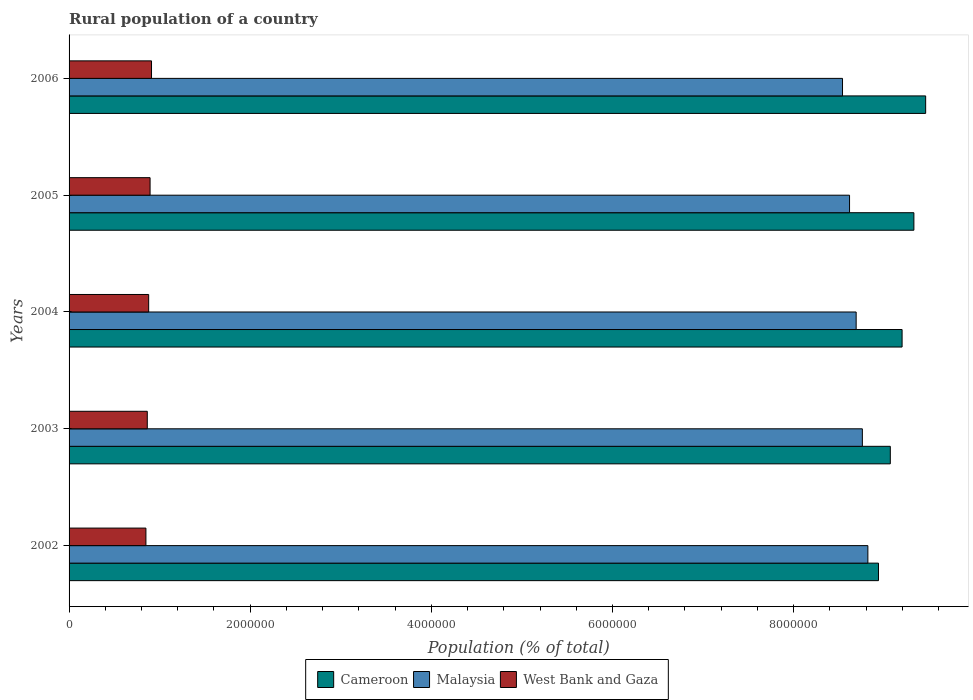How many bars are there on the 1st tick from the top?
Provide a succinct answer. 3. How many bars are there on the 5th tick from the bottom?
Provide a short and direct response. 3. In how many cases, is the number of bars for a given year not equal to the number of legend labels?
Provide a succinct answer. 0. What is the rural population in West Bank and Gaza in 2003?
Provide a short and direct response. 8.64e+05. Across all years, what is the maximum rural population in Malaysia?
Offer a very short reply. 8.82e+06. Across all years, what is the minimum rural population in Cameroon?
Your answer should be very brief. 8.94e+06. In which year was the rural population in Malaysia minimum?
Provide a succinct answer. 2006. What is the total rural population in West Bank and Gaza in the graph?
Offer a terse response. 4.40e+06. What is the difference between the rural population in Malaysia in 2005 and that in 2006?
Give a very brief answer. 7.75e+04. What is the difference between the rural population in West Bank and Gaza in 2005 and the rural population in Cameroon in 2003?
Your answer should be compact. -8.17e+06. What is the average rural population in Malaysia per year?
Provide a short and direct response. 8.69e+06. In the year 2004, what is the difference between the rural population in Malaysia and rural population in West Bank and Gaza?
Ensure brevity in your answer.  7.81e+06. In how many years, is the rural population in Malaysia greater than 2000000 %?
Provide a short and direct response. 5. What is the ratio of the rural population in West Bank and Gaza in 2004 to that in 2006?
Your answer should be compact. 0.97. What is the difference between the highest and the second highest rural population in West Bank and Gaza?
Offer a terse response. 1.58e+04. What is the difference between the highest and the lowest rural population in West Bank and Gaza?
Your response must be concise. 6.18e+04. In how many years, is the rural population in Cameroon greater than the average rural population in Cameroon taken over all years?
Keep it short and to the point. 3. Is the sum of the rural population in Malaysia in 2002 and 2004 greater than the maximum rural population in Cameroon across all years?
Your response must be concise. Yes. What does the 2nd bar from the top in 2006 represents?
Make the answer very short. Malaysia. What does the 3rd bar from the bottom in 2005 represents?
Your answer should be very brief. West Bank and Gaza. Is it the case that in every year, the sum of the rural population in Malaysia and rural population in Cameroon is greater than the rural population in West Bank and Gaza?
Make the answer very short. Yes. How many bars are there?
Provide a short and direct response. 15. How many years are there in the graph?
Ensure brevity in your answer.  5. Are the values on the major ticks of X-axis written in scientific E-notation?
Give a very brief answer. No. Does the graph contain grids?
Offer a very short reply. No. Where does the legend appear in the graph?
Your answer should be compact. Bottom center. How many legend labels are there?
Offer a very short reply. 3. What is the title of the graph?
Give a very brief answer. Rural population of a country. What is the label or title of the X-axis?
Ensure brevity in your answer.  Population (% of total). What is the Population (% of total) in Cameroon in 2002?
Make the answer very short. 8.94e+06. What is the Population (% of total) in Malaysia in 2002?
Offer a terse response. 8.82e+06. What is the Population (% of total) of West Bank and Gaza in 2002?
Offer a terse response. 8.49e+05. What is the Population (% of total) in Cameroon in 2003?
Keep it short and to the point. 9.07e+06. What is the Population (% of total) in Malaysia in 2003?
Offer a very short reply. 8.76e+06. What is the Population (% of total) in West Bank and Gaza in 2003?
Make the answer very short. 8.64e+05. What is the Population (% of total) in Cameroon in 2004?
Your answer should be compact. 9.20e+06. What is the Population (% of total) of Malaysia in 2004?
Give a very brief answer. 8.69e+06. What is the Population (% of total) of West Bank and Gaza in 2004?
Give a very brief answer. 8.79e+05. What is the Population (% of total) of Cameroon in 2005?
Give a very brief answer. 9.33e+06. What is the Population (% of total) in Malaysia in 2005?
Make the answer very short. 8.62e+06. What is the Population (% of total) of West Bank and Gaza in 2005?
Offer a terse response. 8.94e+05. What is the Population (% of total) of Cameroon in 2006?
Give a very brief answer. 9.46e+06. What is the Population (% of total) in Malaysia in 2006?
Your answer should be compact. 8.54e+06. What is the Population (% of total) in West Bank and Gaza in 2006?
Keep it short and to the point. 9.10e+05. Across all years, what is the maximum Population (% of total) of Cameroon?
Offer a terse response. 9.46e+06. Across all years, what is the maximum Population (% of total) of Malaysia?
Your response must be concise. 8.82e+06. Across all years, what is the maximum Population (% of total) in West Bank and Gaza?
Give a very brief answer. 9.10e+05. Across all years, what is the minimum Population (% of total) of Cameroon?
Your answer should be compact. 8.94e+06. Across all years, what is the minimum Population (% of total) in Malaysia?
Offer a very short reply. 8.54e+06. Across all years, what is the minimum Population (% of total) in West Bank and Gaza?
Provide a succinct answer. 8.49e+05. What is the total Population (% of total) of Cameroon in the graph?
Your answer should be very brief. 4.60e+07. What is the total Population (% of total) of Malaysia in the graph?
Offer a very short reply. 4.34e+07. What is the total Population (% of total) in West Bank and Gaza in the graph?
Provide a short and direct response. 4.40e+06. What is the difference between the Population (% of total) of Cameroon in 2002 and that in 2003?
Ensure brevity in your answer.  -1.31e+05. What is the difference between the Population (% of total) in Malaysia in 2002 and that in 2003?
Give a very brief answer. 6.08e+04. What is the difference between the Population (% of total) of West Bank and Gaza in 2002 and that in 2003?
Ensure brevity in your answer.  -1.51e+04. What is the difference between the Population (% of total) in Cameroon in 2002 and that in 2004?
Your answer should be very brief. -2.61e+05. What is the difference between the Population (% of total) of Malaysia in 2002 and that in 2004?
Offer a terse response. 1.29e+05. What is the difference between the Population (% of total) in West Bank and Gaza in 2002 and that in 2004?
Give a very brief answer. -3.04e+04. What is the difference between the Population (% of total) in Cameroon in 2002 and that in 2005?
Your response must be concise. -3.91e+05. What is the difference between the Population (% of total) of Malaysia in 2002 and that in 2005?
Provide a succinct answer. 2.02e+05. What is the difference between the Population (% of total) of West Bank and Gaza in 2002 and that in 2005?
Make the answer very short. -4.60e+04. What is the difference between the Population (% of total) in Cameroon in 2002 and that in 2006?
Your response must be concise. -5.21e+05. What is the difference between the Population (% of total) of Malaysia in 2002 and that in 2006?
Your answer should be very brief. 2.80e+05. What is the difference between the Population (% of total) in West Bank and Gaza in 2002 and that in 2006?
Give a very brief answer. -6.18e+04. What is the difference between the Population (% of total) of Cameroon in 2003 and that in 2004?
Your response must be concise. -1.30e+05. What is the difference between the Population (% of total) in Malaysia in 2003 and that in 2004?
Provide a short and direct response. 6.86e+04. What is the difference between the Population (% of total) in West Bank and Gaza in 2003 and that in 2004?
Provide a succinct answer. -1.53e+04. What is the difference between the Population (% of total) of Cameroon in 2003 and that in 2005?
Offer a terse response. -2.60e+05. What is the difference between the Population (% of total) in Malaysia in 2003 and that in 2005?
Your response must be concise. 1.42e+05. What is the difference between the Population (% of total) of West Bank and Gaza in 2003 and that in 2005?
Offer a terse response. -3.09e+04. What is the difference between the Population (% of total) of Cameroon in 2003 and that in 2006?
Give a very brief answer. -3.90e+05. What is the difference between the Population (% of total) in Malaysia in 2003 and that in 2006?
Your answer should be very brief. 2.19e+05. What is the difference between the Population (% of total) of West Bank and Gaza in 2003 and that in 2006?
Keep it short and to the point. -4.67e+04. What is the difference between the Population (% of total) in Cameroon in 2004 and that in 2005?
Provide a succinct answer. -1.30e+05. What is the difference between the Population (% of total) of Malaysia in 2004 and that in 2005?
Give a very brief answer. 7.30e+04. What is the difference between the Population (% of total) of West Bank and Gaza in 2004 and that in 2005?
Your answer should be compact. -1.56e+04. What is the difference between the Population (% of total) of Cameroon in 2004 and that in 2006?
Provide a short and direct response. -2.60e+05. What is the difference between the Population (% of total) of Malaysia in 2004 and that in 2006?
Ensure brevity in your answer.  1.50e+05. What is the difference between the Population (% of total) in West Bank and Gaza in 2004 and that in 2006?
Your answer should be very brief. -3.14e+04. What is the difference between the Population (% of total) of Cameroon in 2005 and that in 2006?
Your response must be concise. -1.30e+05. What is the difference between the Population (% of total) of Malaysia in 2005 and that in 2006?
Your answer should be very brief. 7.75e+04. What is the difference between the Population (% of total) of West Bank and Gaza in 2005 and that in 2006?
Give a very brief answer. -1.58e+04. What is the difference between the Population (% of total) in Cameroon in 2002 and the Population (% of total) in Malaysia in 2003?
Ensure brevity in your answer.  1.78e+05. What is the difference between the Population (% of total) of Cameroon in 2002 and the Population (% of total) of West Bank and Gaza in 2003?
Give a very brief answer. 8.07e+06. What is the difference between the Population (% of total) of Malaysia in 2002 and the Population (% of total) of West Bank and Gaza in 2003?
Your answer should be very brief. 7.96e+06. What is the difference between the Population (% of total) in Cameroon in 2002 and the Population (% of total) in Malaysia in 2004?
Ensure brevity in your answer.  2.47e+05. What is the difference between the Population (% of total) of Cameroon in 2002 and the Population (% of total) of West Bank and Gaza in 2004?
Provide a short and direct response. 8.06e+06. What is the difference between the Population (% of total) in Malaysia in 2002 and the Population (% of total) in West Bank and Gaza in 2004?
Provide a succinct answer. 7.94e+06. What is the difference between the Population (% of total) in Cameroon in 2002 and the Population (% of total) in Malaysia in 2005?
Offer a very short reply. 3.20e+05. What is the difference between the Population (% of total) of Cameroon in 2002 and the Population (% of total) of West Bank and Gaza in 2005?
Your answer should be compact. 8.04e+06. What is the difference between the Population (% of total) in Malaysia in 2002 and the Population (% of total) in West Bank and Gaza in 2005?
Your answer should be very brief. 7.93e+06. What is the difference between the Population (% of total) in Cameroon in 2002 and the Population (% of total) in Malaysia in 2006?
Ensure brevity in your answer.  3.97e+05. What is the difference between the Population (% of total) in Cameroon in 2002 and the Population (% of total) in West Bank and Gaza in 2006?
Your response must be concise. 8.03e+06. What is the difference between the Population (% of total) of Malaysia in 2002 and the Population (% of total) of West Bank and Gaza in 2006?
Give a very brief answer. 7.91e+06. What is the difference between the Population (% of total) of Cameroon in 2003 and the Population (% of total) of Malaysia in 2004?
Give a very brief answer. 3.77e+05. What is the difference between the Population (% of total) in Cameroon in 2003 and the Population (% of total) in West Bank and Gaza in 2004?
Give a very brief answer. 8.19e+06. What is the difference between the Population (% of total) in Malaysia in 2003 and the Population (% of total) in West Bank and Gaza in 2004?
Provide a short and direct response. 7.88e+06. What is the difference between the Population (% of total) in Cameroon in 2003 and the Population (% of total) in Malaysia in 2005?
Your answer should be very brief. 4.50e+05. What is the difference between the Population (% of total) of Cameroon in 2003 and the Population (% of total) of West Bank and Gaza in 2005?
Your answer should be very brief. 8.17e+06. What is the difference between the Population (% of total) in Malaysia in 2003 and the Population (% of total) in West Bank and Gaza in 2005?
Ensure brevity in your answer.  7.86e+06. What is the difference between the Population (% of total) of Cameroon in 2003 and the Population (% of total) of Malaysia in 2006?
Your answer should be very brief. 5.28e+05. What is the difference between the Population (% of total) in Cameroon in 2003 and the Population (% of total) in West Bank and Gaza in 2006?
Offer a very short reply. 8.16e+06. What is the difference between the Population (% of total) in Malaysia in 2003 and the Population (% of total) in West Bank and Gaza in 2006?
Ensure brevity in your answer.  7.85e+06. What is the difference between the Population (% of total) in Cameroon in 2004 and the Population (% of total) in Malaysia in 2005?
Your answer should be compact. 5.80e+05. What is the difference between the Population (% of total) in Cameroon in 2004 and the Population (% of total) in West Bank and Gaza in 2005?
Your response must be concise. 8.30e+06. What is the difference between the Population (% of total) in Malaysia in 2004 and the Population (% of total) in West Bank and Gaza in 2005?
Provide a succinct answer. 7.80e+06. What is the difference between the Population (% of total) of Cameroon in 2004 and the Population (% of total) of Malaysia in 2006?
Your answer should be compact. 6.58e+05. What is the difference between the Population (% of total) in Cameroon in 2004 and the Population (% of total) in West Bank and Gaza in 2006?
Make the answer very short. 8.29e+06. What is the difference between the Population (% of total) in Malaysia in 2004 and the Population (% of total) in West Bank and Gaza in 2006?
Give a very brief answer. 7.78e+06. What is the difference between the Population (% of total) in Cameroon in 2005 and the Population (% of total) in Malaysia in 2006?
Your answer should be very brief. 7.88e+05. What is the difference between the Population (% of total) of Cameroon in 2005 and the Population (% of total) of West Bank and Gaza in 2006?
Provide a short and direct response. 8.42e+06. What is the difference between the Population (% of total) in Malaysia in 2005 and the Population (% of total) in West Bank and Gaza in 2006?
Offer a very short reply. 7.71e+06. What is the average Population (% of total) in Cameroon per year?
Provide a succinct answer. 9.20e+06. What is the average Population (% of total) in Malaysia per year?
Give a very brief answer. 8.69e+06. What is the average Population (% of total) in West Bank and Gaza per year?
Keep it short and to the point. 8.79e+05. In the year 2002, what is the difference between the Population (% of total) in Cameroon and Population (% of total) in Malaysia?
Your answer should be compact. 1.17e+05. In the year 2002, what is the difference between the Population (% of total) of Cameroon and Population (% of total) of West Bank and Gaza?
Keep it short and to the point. 8.09e+06. In the year 2002, what is the difference between the Population (% of total) in Malaysia and Population (% of total) in West Bank and Gaza?
Keep it short and to the point. 7.97e+06. In the year 2003, what is the difference between the Population (% of total) in Cameroon and Population (% of total) in Malaysia?
Provide a succinct answer. 3.09e+05. In the year 2003, what is the difference between the Population (% of total) of Cameroon and Population (% of total) of West Bank and Gaza?
Offer a terse response. 8.20e+06. In the year 2003, what is the difference between the Population (% of total) of Malaysia and Population (% of total) of West Bank and Gaza?
Give a very brief answer. 7.90e+06. In the year 2004, what is the difference between the Population (% of total) in Cameroon and Population (% of total) in Malaysia?
Provide a short and direct response. 5.07e+05. In the year 2004, what is the difference between the Population (% of total) in Cameroon and Population (% of total) in West Bank and Gaza?
Give a very brief answer. 8.32e+06. In the year 2004, what is the difference between the Population (% of total) in Malaysia and Population (% of total) in West Bank and Gaza?
Provide a short and direct response. 7.81e+06. In the year 2005, what is the difference between the Population (% of total) in Cameroon and Population (% of total) in Malaysia?
Provide a short and direct response. 7.11e+05. In the year 2005, what is the difference between the Population (% of total) of Cameroon and Population (% of total) of West Bank and Gaza?
Provide a succinct answer. 8.43e+06. In the year 2005, what is the difference between the Population (% of total) of Malaysia and Population (% of total) of West Bank and Gaza?
Your answer should be compact. 7.72e+06. In the year 2006, what is the difference between the Population (% of total) in Cameroon and Population (% of total) in Malaysia?
Offer a very short reply. 9.18e+05. In the year 2006, what is the difference between the Population (% of total) of Cameroon and Population (% of total) of West Bank and Gaza?
Your answer should be very brief. 8.55e+06. In the year 2006, what is the difference between the Population (% of total) of Malaysia and Population (% of total) of West Bank and Gaza?
Offer a terse response. 7.63e+06. What is the ratio of the Population (% of total) of Cameroon in 2002 to that in 2003?
Provide a succinct answer. 0.99. What is the ratio of the Population (% of total) in West Bank and Gaza in 2002 to that in 2003?
Give a very brief answer. 0.98. What is the ratio of the Population (% of total) in Cameroon in 2002 to that in 2004?
Give a very brief answer. 0.97. What is the ratio of the Population (% of total) in Malaysia in 2002 to that in 2004?
Provide a short and direct response. 1.01. What is the ratio of the Population (% of total) of West Bank and Gaza in 2002 to that in 2004?
Give a very brief answer. 0.97. What is the ratio of the Population (% of total) in Cameroon in 2002 to that in 2005?
Offer a terse response. 0.96. What is the ratio of the Population (% of total) in Malaysia in 2002 to that in 2005?
Offer a terse response. 1.02. What is the ratio of the Population (% of total) in West Bank and Gaza in 2002 to that in 2005?
Keep it short and to the point. 0.95. What is the ratio of the Population (% of total) in Cameroon in 2002 to that in 2006?
Give a very brief answer. 0.94. What is the ratio of the Population (% of total) of Malaysia in 2002 to that in 2006?
Offer a terse response. 1.03. What is the ratio of the Population (% of total) in West Bank and Gaza in 2002 to that in 2006?
Your response must be concise. 0.93. What is the ratio of the Population (% of total) of Cameroon in 2003 to that in 2004?
Give a very brief answer. 0.99. What is the ratio of the Population (% of total) of Malaysia in 2003 to that in 2004?
Your response must be concise. 1.01. What is the ratio of the Population (% of total) of West Bank and Gaza in 2003 to that in 2004?
Make the answer very short. 0.98. What is the ratio of the Population (% of total) of Cameroon in 2003 to that in 2005?
Your answer should be compact. 0.97. What is the ratio of the Population (% of total) of Malaysia in 2003 to that in 2005?
Offer a terse response. 1.02. What is the ratio of the Population (% of total) in West Bank and Gaza in 2003 to that in 2005?
Give a very brief answer. 0.97. What is the ratio of the Population (% of total) in Cameroon in 2003 to that in 2006?
Give a very brief answer. 0.96. What is the ratio of the Population (% of total) in Malaysia in 2003 to that in 2006?
Your answer should be very brief. 1.03. What is the ratio of the Population (% of total) of West Bank and Gaza in 2003 to that in 2006?
Give a very brief answer. 0.95. What is the ratio of the Population (% of total) of Cameroon in 2004 to that in 2005?
Give a very brief answer. 0.99. What is the ratio of the Population (% of total) of Malaysia in 2004 to that in 2005?
Your response must be concise. 1.01. What is the ratio of the Population (% of total) in West Bank and Gaza in 2004 to that in 2005?
Keep it short and to the point. 0.98. What is the ratio of the Population (% of total) of Cameroon in 2004 to that in 2006?
Provide a succinct answer. 0.97. What is the ratio of the Population (% of total) of Malaysia in 2004 to that in 2006?
Your answer should be compact. 1.02. What is the ratio of the Population (% of total) of West Bank and Gaza in 2004 to that in 2006?
Keep it short and to the point. 0.97. What is the ratio of the Population (% of total) of Cameroon in 2005 to that in 2006?
Your response must be concise. 0.99. What is the ratio of the Population (% of total) in Malaysia in 2005 to that in 2006?
Your response must be concise. 1.01. What is the ratio of the Population (% of total) in West Bank and Gaza in 2005 to that in 2006?
Ensure brevity in your answer.  0.98. What is the difference between the highest and the second highest Population (% of total) in Cameroon?
Make the answer very short. 1.30e+05. What is the difference between the highest and the second highest Population (% of total) in Malaysia?
Your answer should be compact. 6.08e+04. What is the difference between the highest and the second highest Population (% of total) of West Bank and Gaza?
Offer a terse response. 1.58e+04. What is the difference between the highest and the lowest Population (% of total) in Cameroon?
Your answer should be very brief. 5.21e+05. What is the difference between the highest and the lowest Population (% of total) of Malaysia?
Keep it short and to the point. 2.80e+05. What is the difference between the highest and the lowest Population (% of total) in West Bank and Gaza?
Provide a succinct answer. 6.18e+04. 